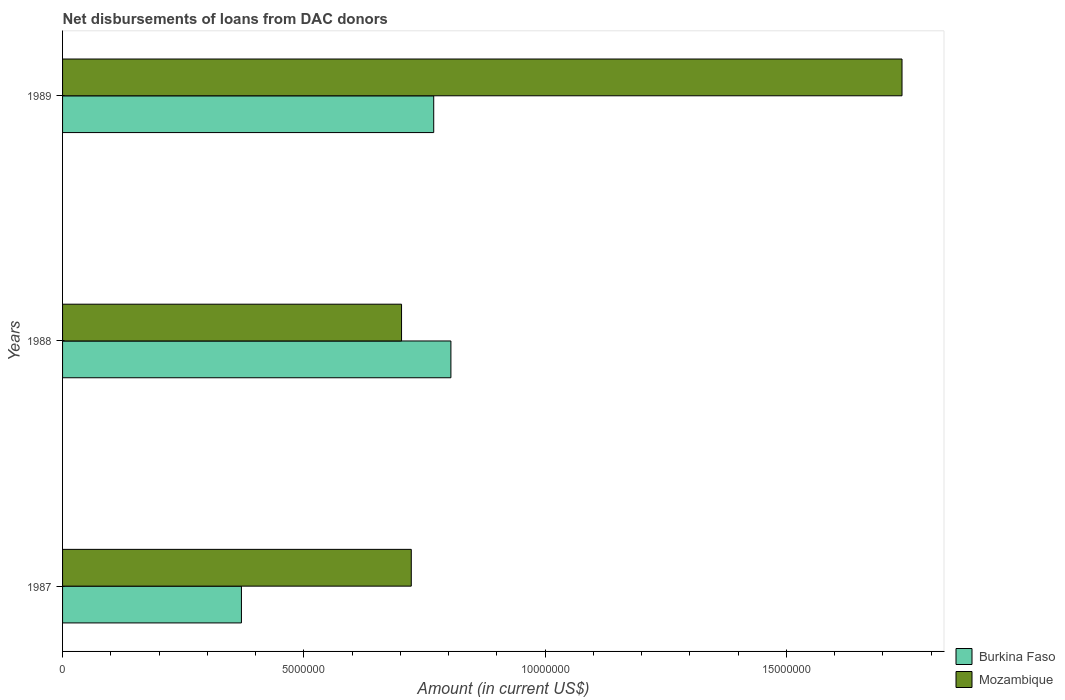How many different coloured bars are there?
Provide a short and direct response. 2. How many groups of bars are there?
Make the answer very short. 3. How many bars are there on the 2nd tick from the top?
Your answer should be very brief. 2. How many bars are there on the 3rd tick from the bottom?
Your response must be concise. 2. What is the label of the 3rd group of bars from the top?
Ensure brevity in your answer.  1987. In how many cases, is the number of bars for a given year not equal to the number of legend labels?
Provide a succinct answer. 0. What is the amount of loans disbursed in Burkina Faso in 1988?
Provide a succinct answer. 8.05e+06. Across all years, what is the maximum amount of loans disbursed in Burkina Faso?
Offer a very short reply. 8.05e+06. Across all years, what is the minimum amount of loans disbursed in Mozambique?
Provide a short and direct response. 7.02e+06. In which year was the amount of loans disbursed in Burkina Faso minimum?
Make the answer very short. 1987. What is the total amount of loans disbursed in Mozambique in the graph?
Your answer should be very brief. 3.16e+07. What is the difference between the amount of loans disbursed in Mozambique in 1988 and that in 1989?
Your answer should be very brief. -1.04e+07. What is the difference between the amount of loans disbursed in Burkina Faso in 1987 and the amount of loans disbursed in Mozambique in 1988?
Provide a short and direct response. -3.32e+06. What is the average amount of loans disbursed in Burkina Faso per year?
Ensure brevity in your answer.  6.48e+06. In the year 1988, what is the difference between the amount of loans disbursed in Mozambique and amount of loans disbursed in Burkina Faso?
Give a very brief answer. -1.02e+06. In how many years, is the amount of loans disbursed in Burkina Faso greater than 12000000 US$?
Offer a very short reply. 0. What is the ratio of the amount of loans disbursed in Mozambique in 1987 to that in 1988?
Ensure brevity in your answer.  1.03. What is the difference between the highest and the second highest amount of loans disbursed in Mozambique?
Give a very brief answer. 1.02e+07. What is the difference between the highest and the lowest amount of loans disbursed in Burkina Faso?
Ensure brevity in your answer.  4.34e+06. In how many years, is the amount of loans disbursed in Burkina Faso greater than the average amount of loans disbursed in Burkina Faso taken over all years?
Ensure brevity in your answer.  2. What does the 1st bar from the top in 1989 represents?
Offer a terse response. Mozambique. What does the 1st bar from the bottom in 1988 represents?
Ensure brevity in your answer.  Burkina Faso. How many bars are there?
Your response must be concise. 6. Are all the bars in the graph horizontal?
Give a very brief answer. Yes. How many years are there in the graph?
Make the answer very short. 3. Are the values on the major ticks of X-axis written in scientific E-notation?
Give a very brief answer. No. How many legend labels are there?
Offer a terse response. 2. What is the title of the graph?
Your answer should be very brief. Net disbursements of loans from DAC donors. What is the label or title of the X-axis?
Offer a terse response. Amount (in current US$). What is the Amount (in current US$) in Burkina Faso in 1987?
Provide a short and direct response. 3.71e+06. What is the Amount (in current US$) of Mozambique in 1987?
Give a very brief answer. 7.23e+06. What is the Amount (in current US$) in Burkina Faso in 1988?
Your answer should be very brief. 8.05e+06. What is the Amount (in current US$) in Mozambique in 1988?
Make the answer very short. 7.02e+06. What is the Amount (in current US$) in Burkina Faso in 1989?
Offer a very short reply. 7.69e+06. What is the Amount (in current US$) of Mozambique in 1989?
Your answer should be compact. 1.74e+07. Across all years, what is the maximum Amount (in current US$) in Burkina Faso?
Offer a very short reply. 8.05e+06. Across all years, what is the maximum Amount (in current US$) in Mozambique?
Make the answer very short. 1.74e+07. Across all years, what is the minimum Amount (in current US$) of Burkina Faso?
Ensure brevity in your answer.  3.71e+06. Across all years, what is the minimum Amount (in current US$) in Mozambique?
Provide a short and direct response. 7.02e+06. What is the total Amount (in current US$) of Burkina Faso in the graph?
Your answer should be compact. 1.94e+07. What is the total Amount (in current US$) in Mozambique in the graph?
Offer a very short reply. 3.16e+07. What is the difference between the Amount (in current US$) of Burkina Faso in 1987 and that in 1988?
Ensure brevity in your answer.  -4.34e+06. What is the difference between the Amount (in current US$) in Mozambique in 1987 and that in 1988?
Provide a short and direct response. 2.02e+05. What is the difference between the Amount (in current US$) in Burkina Faso in 1987 and that in 1989?
Offer a terse response. -3.98e+06. What is the difference between the Amount (in current US$) of Mozambique in 1987 and that in 1989?
Give a very brief answer. -1.02e+07. What is the difference between the Amount (in current US$) of Burkina Faso in 1988 and that in 1989?
Make the answer very short. 3.56e+05. What is the difference between the Amount (in current US$) of Mozambique in 1988 and that in 1989?
Give a very brief answer. -1.04e+07. What is the difference between the Amount (in current US$) of Burkina Faso in 1987 and the Amount (in current US$) of Mozambique in 1988?
Ensure brevity in your answer.  -3.32e+06. What is the difference between the Amount (in current US$) of Burkina Faso in 1987 and the Amount (in current US$) of Mozambique in 1989?
Provide a short and direct response. -1.37e+07. What is the difference between the Amount (in current US$) of Burkina Faso in 1988 and the Amount (in current US$) of Mozambique in 1989?
Your answer should be compact. -9.35e+06. What is the average Amount (in current US$) in Burkina Faso per year?
Your answer should be very brief. 6.48e+06. What is the average Amount (in current US$) of Mozambique per year?
Your response must be concise. 1.05e+07. In the year 1987, what is the difference between the Amount (in current US$) in Burkina Faso and Amount (in current US$) in Mozambique?
Your answer should be very brief. -3.52e+06. In the year 1988, what is the difference between the Amount (in current US$) in Burkina Faso and Amount (in current US$) in Mozambique?
Ensure brevity in your answer.  1.02e+06. In the year 1989, what is the difference between the Amount (in current US$) of Burkina Faso and Amount (in current US$) of Mozambique?
Offer a very short reply. -9.70e+06. What is the ratio of the Amount (in current US$) in Burkina Faso in 1987 to that in 1988?
Keep it short and to the point. 0.46. What is the ratio of the Amount (in current US$) in Mozambique in 1987 to that in 1988?
Give a very brief answer. 1.03. What is the ratio of the Amount (in current US$) of Burkina Faso in 1987 to that in 1989?
Your answer should be very brief. 0.48. What is the ratio of the Amount (in current US$) in Mozambique in 1987 to that in 1989?
Offer a very short reply. 0.42. What is the ratio of the Amount (in current US$) in Burkina Faso in 1988 to that in 1989?
Your answer should be very brief. 1.05. What is the ratio of the Amount (in current US$) of Mozambique in 1988 to that in 1989?
Your response must be concise. 0.4. What is the difference between the highest and the second highest Amount (in current US$) in Burkina Faso?
Make the answer very short. 3.56e+05. What is the difference between the highest and the second highest Amount (in current US$) in Mozambique?
Provide a succinct answer. 1.02e+07. What is the difference between the highest and the lowest Amount (in current US$) in Burkina Faso?
Provide a short and direct response. 4.34e+06. What is the difference between the highest and the lowest Amount (in current US$) in Mozambique?
Your response must be concise. 1.04e+07. 